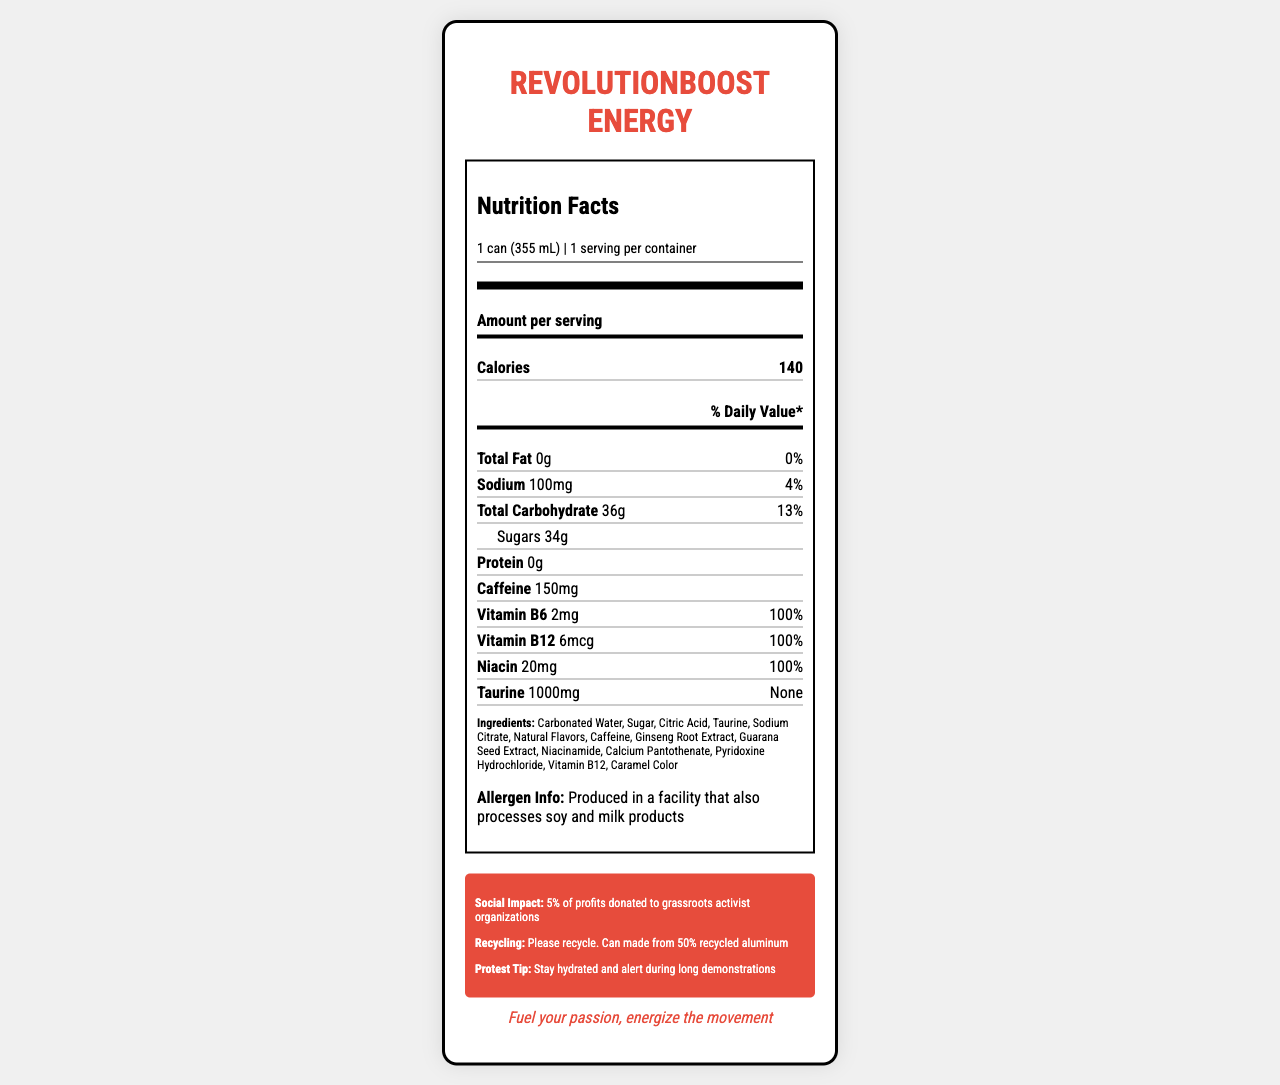How many calories are in one can of RevolutionBoost Energy? The nutrition label states that each serving, which is one can, contains 140 calories.
Answer: 140 calories What is the amount of caffeine in one can of RevolutionBoost Energy? The nutrition label indicates that one can contains 150mg of caffeine.
Answer: 150mg What is the sodium content in one serving? The label shows that the sodium content per serving is 100mg.
Answer: 100mg Which vitamins are included in RevolutionBoost Energy? The ingredients list includes Vitamin B6, Vitamin B12, and Niacin.
Answer: Vitamin B6, Vitamin B12, Niacin What is the serving size of RevolutionBoost Energy? The label specifies that the serving size is 1 can, which equals 355mL.
Answer: 1 can (355 mL) How many grams of sugar are in one serving? The nutrition label indicates that there are 34g of sugar in one serving.
Answer: 34g What percentage of daily value for total carbohydrates does one can provide? A. 5% B. 9% C. 13% D. 20% The daily value percentage for total carbohydrates per serving is listed as 13%.
Answer: C. 13% Which ingredient is listed first? A. Caffeine B. Citric Acid C. Carbonated Water D. Sugar The ingredients list starts with Carbonated Water.
Answer: C. Carbonated Water Is there any fat in RevolutionBoost Energy? The nutrition label indicates that the total fat content is 0g, which means there is no fat in this drink.
Answer: No Does RevolutionBoost Energy contain any allergens? The label mentions that the product is produced in a facility that also processes soy and milk products.
Answer: Yes Can you determine where RevolutionBoost Energy is manufactured? The document doesn't provide information on the specific location where RevolutionBoost Energy is manufactured; it only mentions the manufacturer as SolidariTea Beverages Inc.
Answer: Cannot be determined Summarize the key selling points and social impact of RevolutionBoost Energy. The document highlights the nutritional content of RevolutionBoost Energy along with its social impact initiatives, emphasizing its suitability for social activists with a motivational slogan and a tip for staying hydrated during protests.
Answer: RevolutionBoost Energy is an energy drink that contains 140 calories, 34 grams of sugar, and 150mg of caffeine per can. It provides 100% of the daily value for Vitamin B6, Vitamin B12, and Niacin. Designed for social activists, the product emphasizes social impact by donating 5% of its profits to grassroots organizations and promotes recycling with its can made from 50% recycled aluminum. 